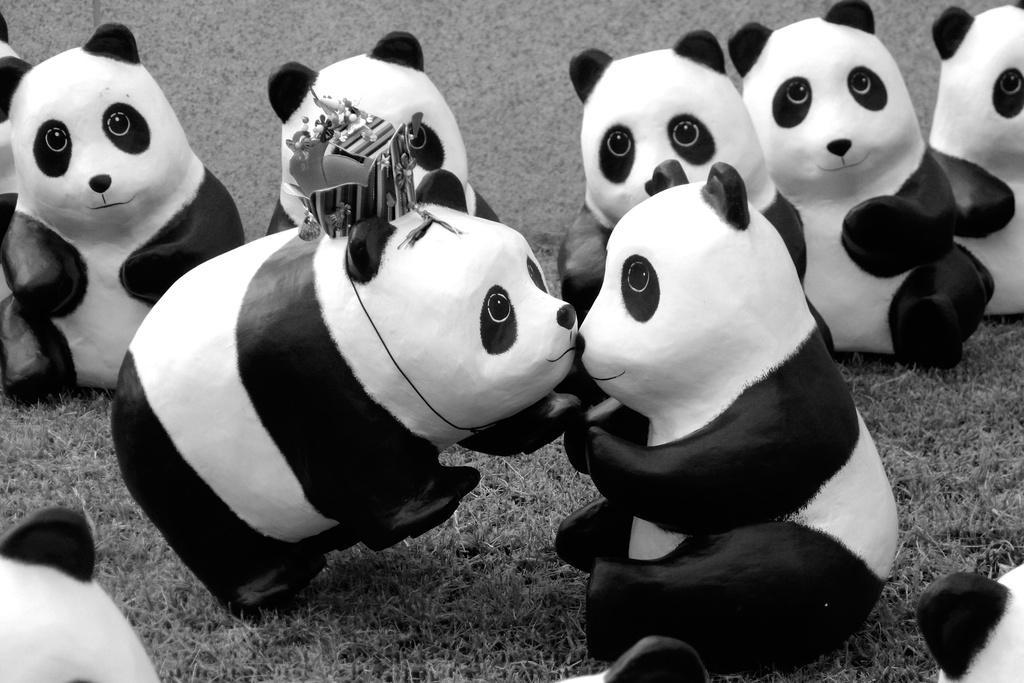Could you give a brief overview of what you see in this image? This is a black and white image. There are many toy pandas. 